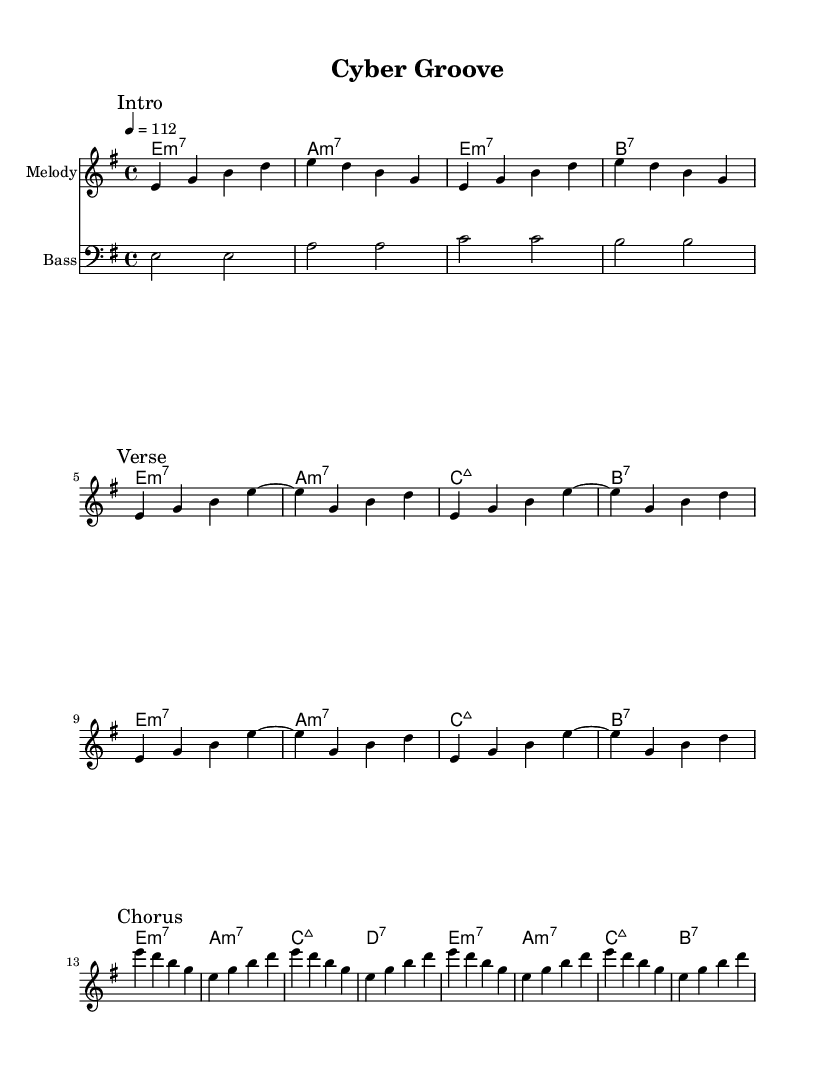What is the key signature of this music? The key signature for the piece is E minor, which has one sharp, F sharp. This is determined by observing the initial markings in the global section.
Answer: E minor What is the time signature of this music? The time signature is 4/4, indicating there are four beats per measure, which is noted in the global section.
Answer: 4/4 What is the tempo marking for this piece? The tempo marking is set at 112 beats per minute, specified with "4 = 112" in the global section.
Answer: 112 How many sections does the composition have? The composition has three main sections: Intro, Verse, and Chorus, identified by the markings in the melody part.
Answer: Three What is the tempo marking in quarter notes for the Chorus? In the Chorus, there are quarter notes played at the tempo of 112 beats per minute, as established by the global section's tempo.
Answer: 112 Which chords are played during the Verse section? The Verse section features the chords E minor 7, A minor 7, and B dominant 7, as indicated by the chord mode in the score where the Verse occurs.
Answer: E minor 7, A minor 7, B7 What bass note is played throughout the piece? The bass line consistently plays E, A, C, and B, as evident in the bassline section, where each measure corresponds to these notes.
Answer: E, A, C, B 